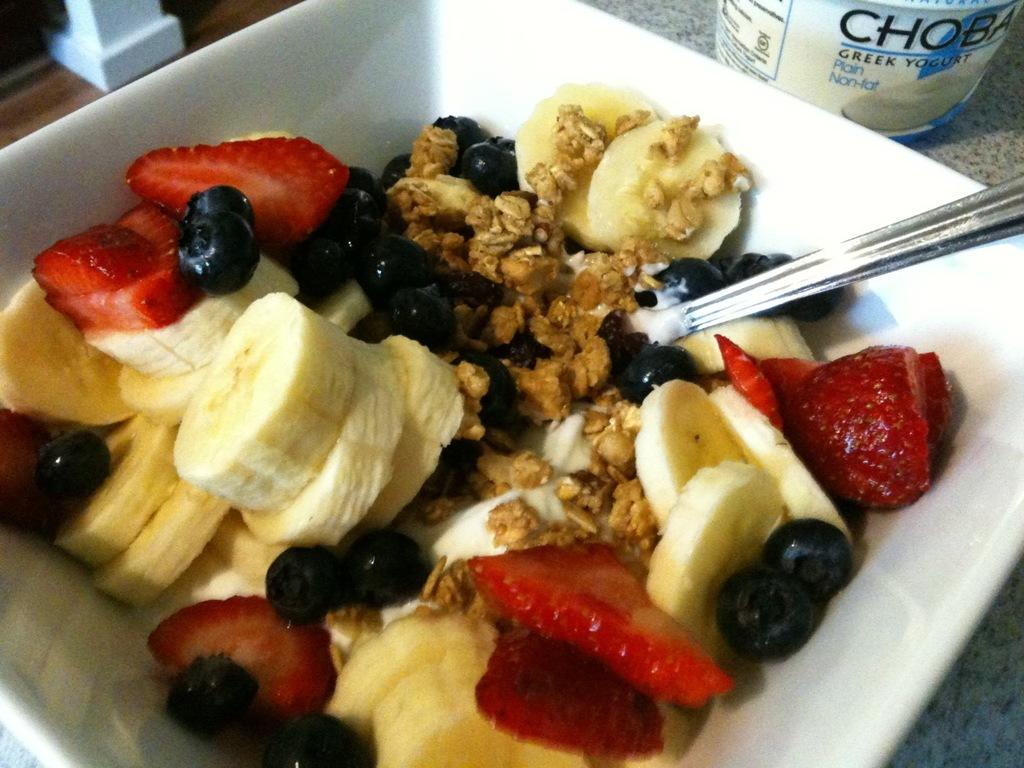What is in the bowl that is visible in the image? There is a bowl with food in the image. What utensil is present in the image? There is a spoon in the image. What can be seen on the table in the image? There is an object on the table in the image. What type of pet can be seen interacting with the food in the image? There is no pet present in the image; it only features a bowl with food, a spoon, and an object on the table. 